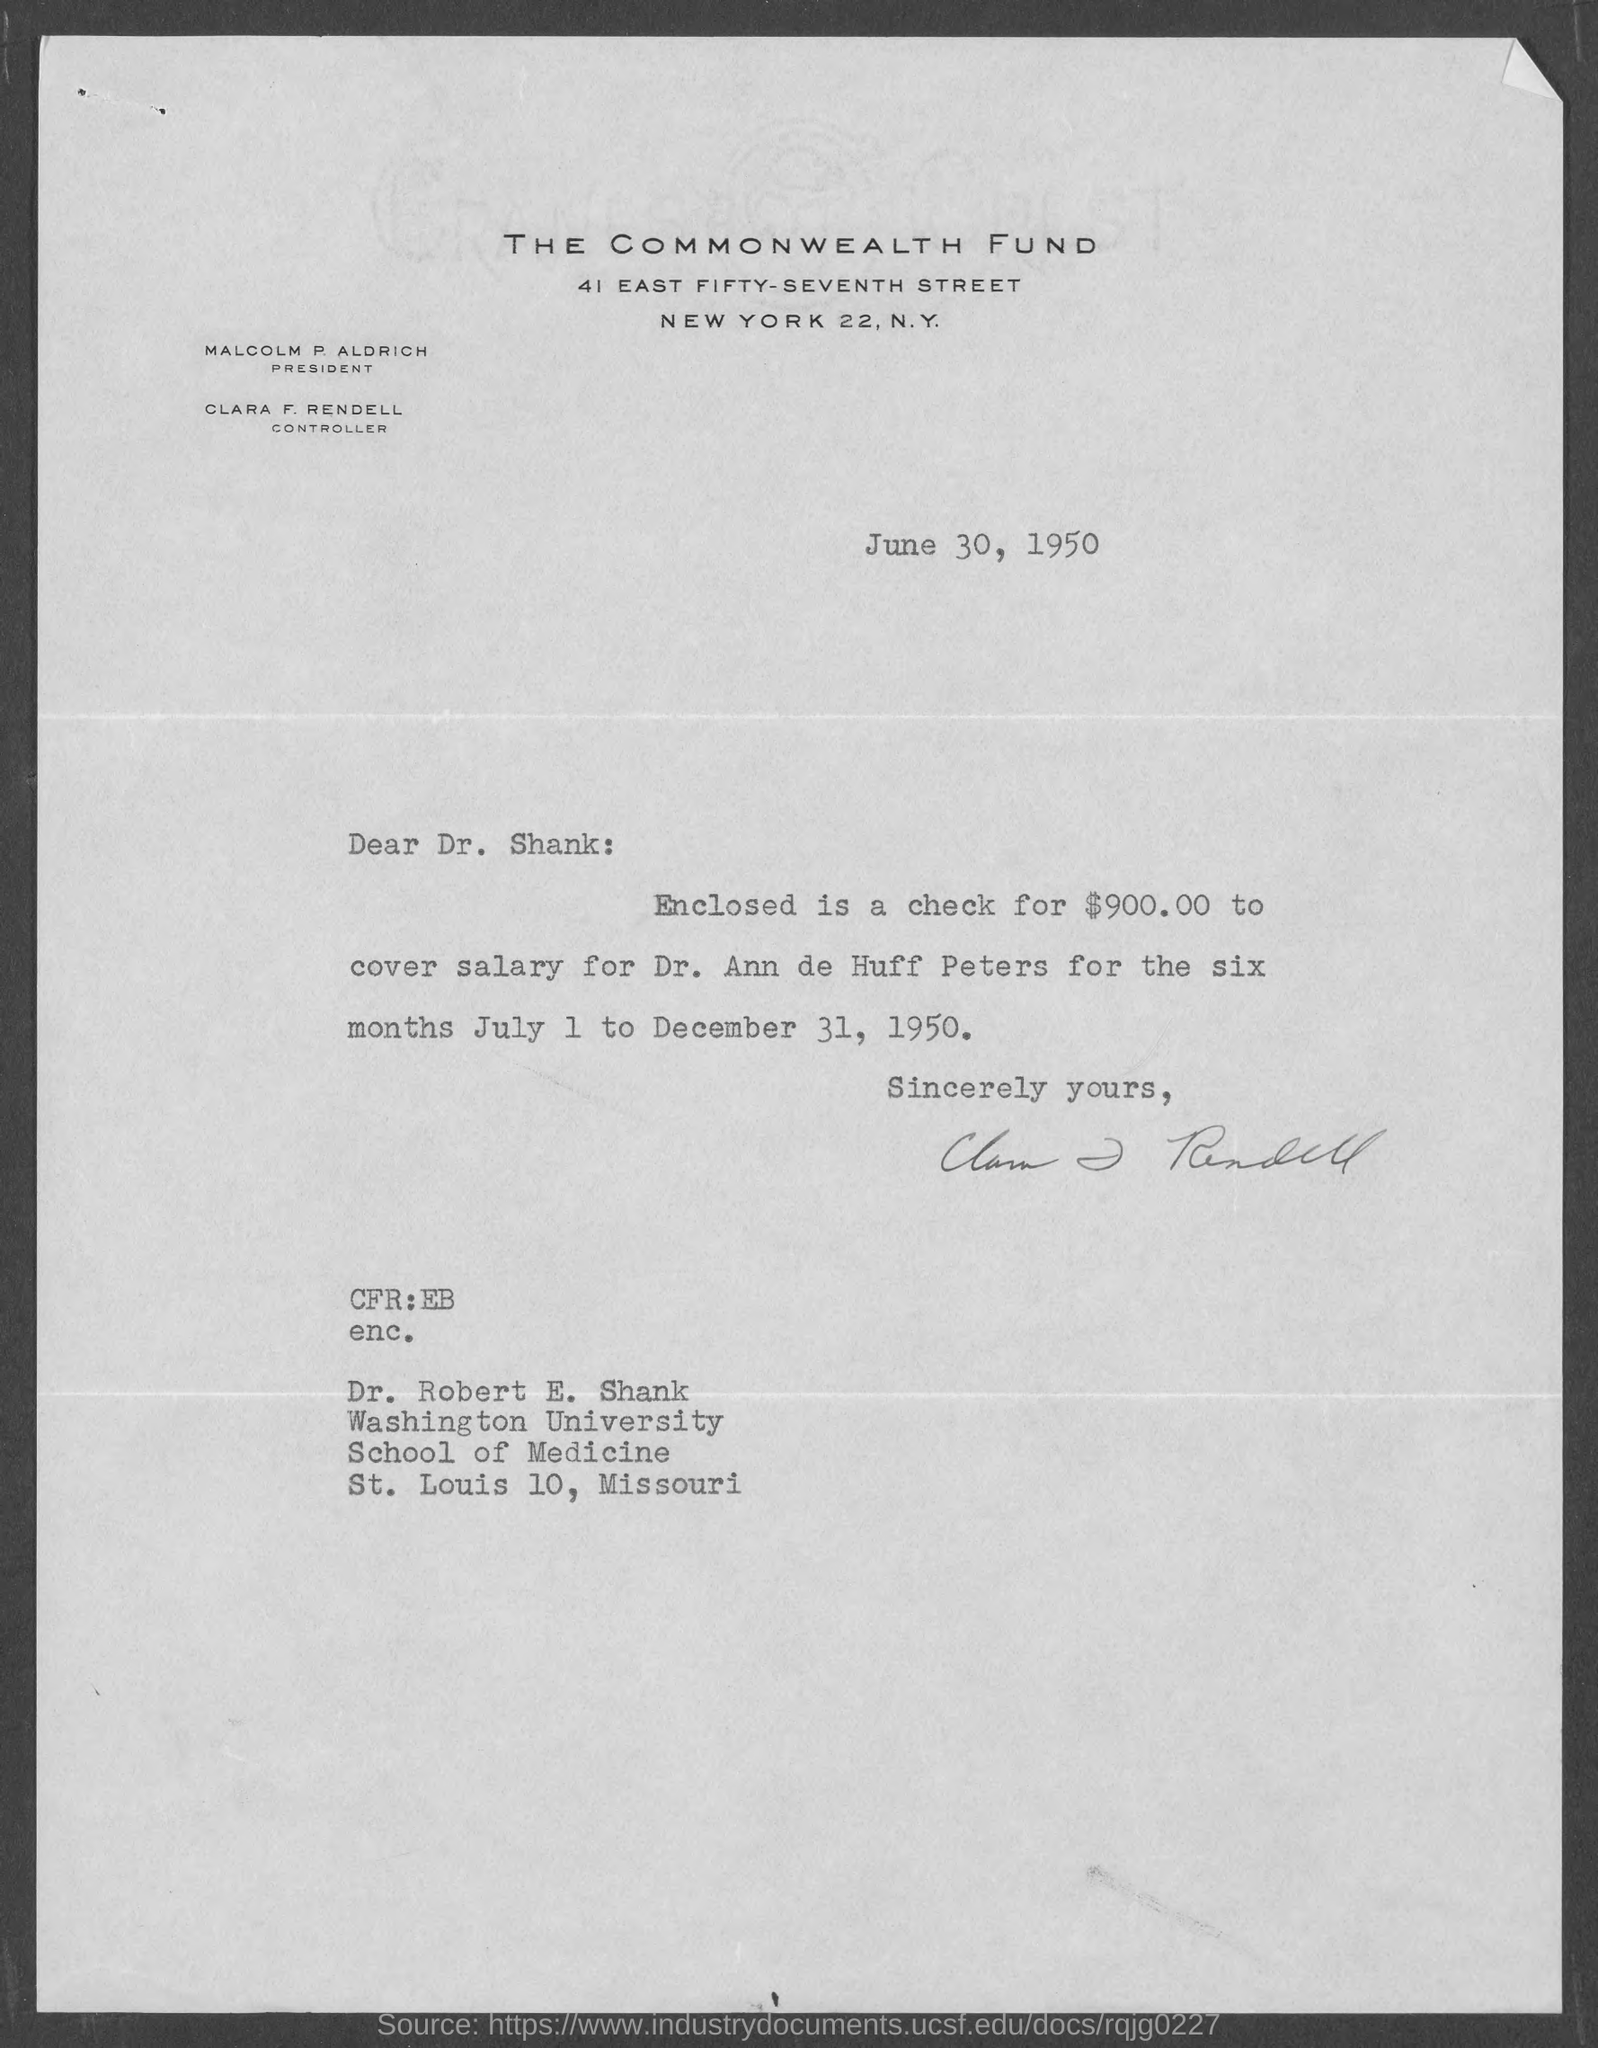The letter is dated on?
Your answer should be very brief. June 30, 1950. Who is the president, the commonwealth fund ?
Give a very brief answer. Malcolm P. Aldrich. Who is the controller, the commonwealth fund?
Give a very brief answer. Clara F. Rendell. What is the amount in the check enclosed with letter ?
Your response must be concise. $900.00. What is the check enclosed for ?
Your answer should be very brief. To cover salary for dr. ann de huff peters. What is the address of washington university school of medicine?
Keep it short and to the point. St. Louis 10, Missouri. 